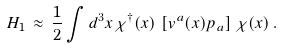<formula> <loc_0><loc_0><loc_500><loc_500>H _ { 1 } \, \approx \, \frac { 1 } { 2 } \int d ^ { 3 } x \, \chi ^ { \dagger } ( { x } ) \, \left [ v ^ { a } ( x ) p _ { a } \right ] \, \chi ( { x } ) \, .</formula> 